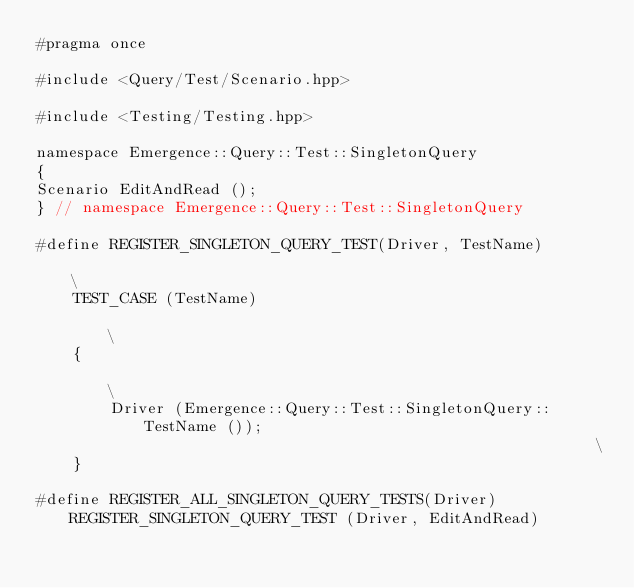<code> <loc_0><loc_0><loc_500><loc_500><_C++_>#pragma once

#include <Query/Test/Scenario.hpp>

#include <Testing/Testing.hpp>

namespace Emergence::Query::Test::SingletonQuery
{
Scenario EditAndRead ();
} // namespace Emergence::Query::Test::SingletonQuery

#define REGISTER_SINGLETON_QUERY_TEST(Driver, TestName)                                                                \
    TEST_CASE (TestName)                                                                                               \
    {                                                                                                                  \
        Driver (Emergence::Query::Test::SingletonQuery::TestName ());                                                  \
    }

#define REGISTER_ALL_SINGLETON_QUERY_TESTS(Driver) REGISTER_SINGLETON_QUERY_TEST (Driver, EditAndRead)
</code> 